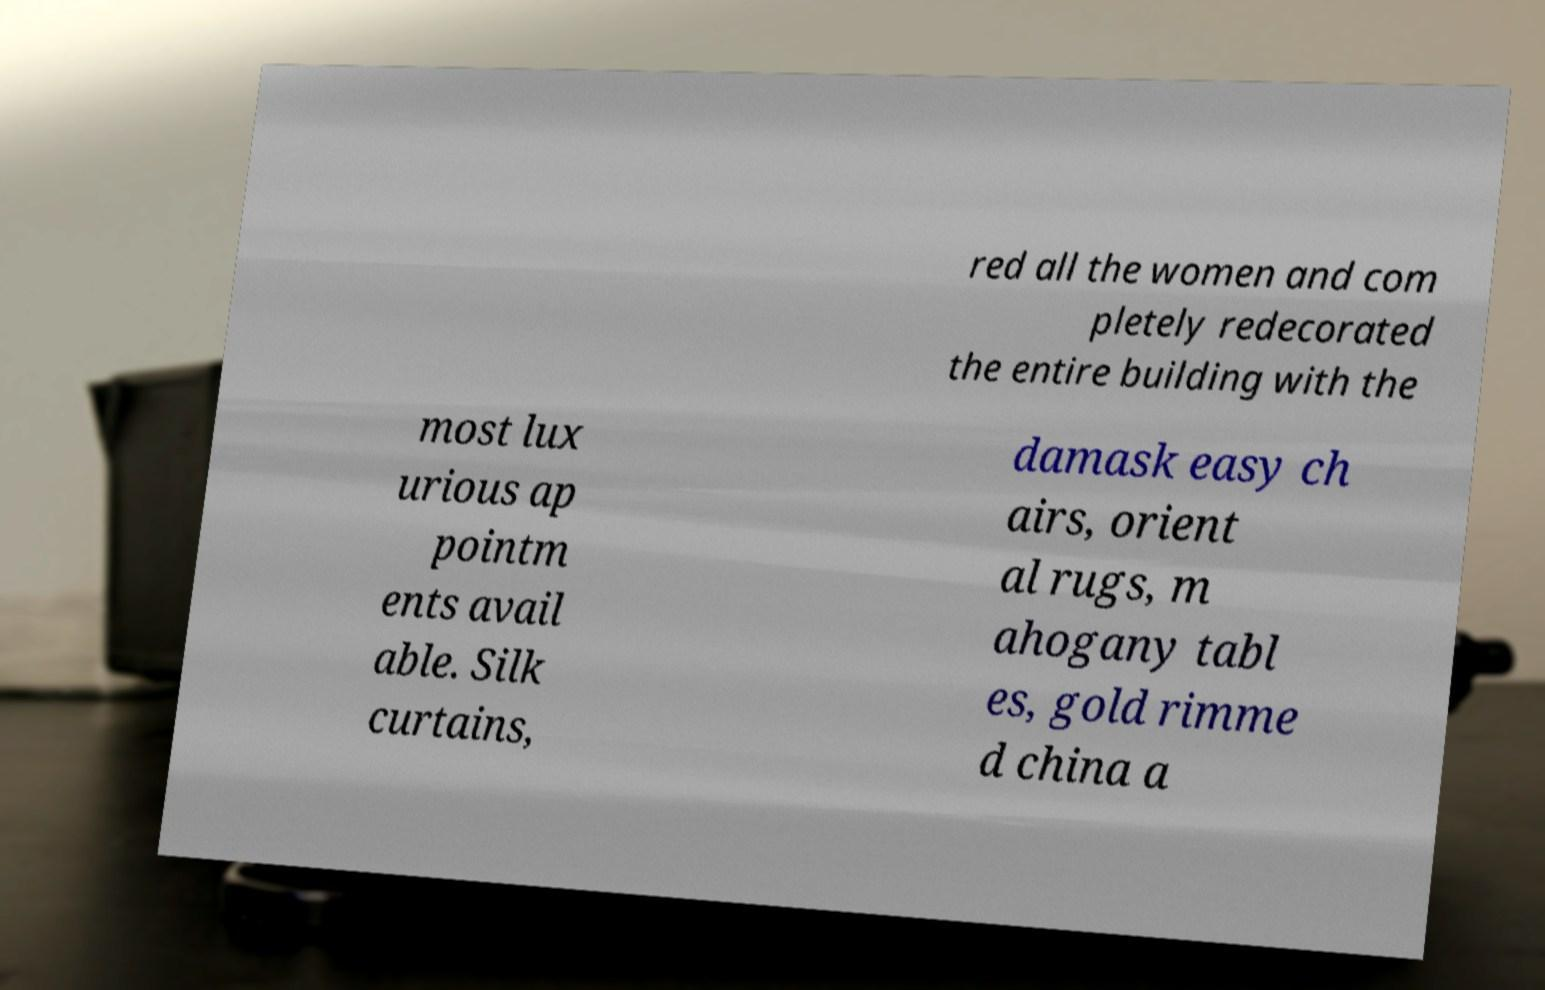There's text embedded in this image that I need extracted. Can you transcribe it verbatim? red all the women and com pletely redecorated the entire building with the most lux urious ap pointm ents avail able. Silk curtains, damask easy ch airs, orient al rugs, m ahogany tabl es, gold rimme d china a 